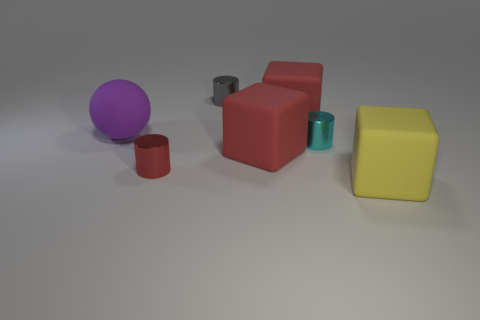Do the big red object in front of the large ball and the red cylinder have the same material?
Make the answer very short. No. What size is the rubber object that is both behind the tiny cyan cylinder and on the right side of the purple matte thing?
Ensure brevity in your answer.  Large. The matte ball has what color?
Keep it short and to the point. Purple. How many balls are there?
Your answer should be compact. 1. What number of large things are the same color as the big matte ball?
Your answer should be very brief. 0. There is a large object that is to the left of the red metal thing; does it have the same shape as the large red rubber object behind the purple rubber sphere?
Keep it short and to the point. No. What color is the shiny cylinder to the right of the tiny cylinder behind the thing left of the small red cylinder?
Your answer should be compact. Cyan. What is the color of the matte cube behind the purple object?
Give a very brief answer. Red. There is a ball that is the same size as the yellow object; what is its color?
Offer a very short reply. Purple. Do the yellow matte cube and the purple matte object have the same size?
Keep it short and to the point. Yes. 